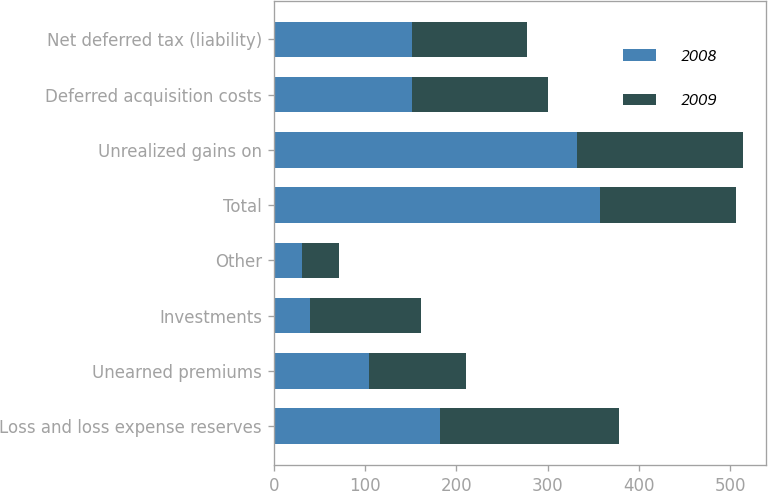<chart> <loc_0><loc_0><loc_500><loc_500><stacked_bar_chart><ecel><fcel>Loss and loss expense reserves<fcel>Unearned premiums<fcel>Investments<fcel>Other<fcel>Total<fcel>Unrealized gains on<fcel>Deferred acquisition costs<fcel>Net deferred tax (liability)<nl><fcel>2008<fcel>182<fcel>104<fcel>40<fcel>31<fcel>357<fcel>332<fcel>152<fcel>152<nl><fcel>2009<fcel>196<fcel>107<fcel>121<fcel>41<fcel>149<fcel>182<fcel>149<fcel>126<nl></chart> 